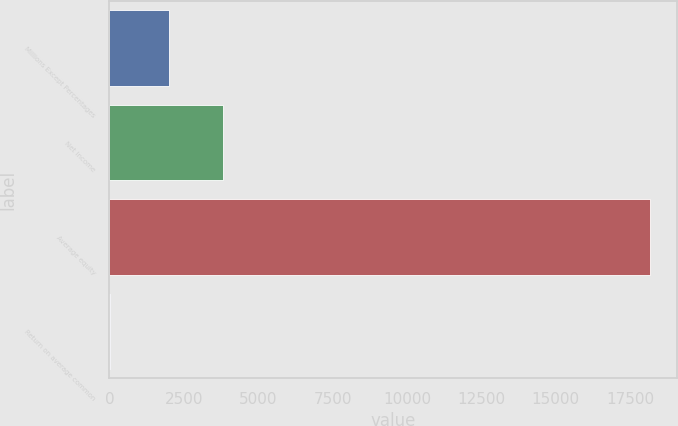Convert chart to OTSL. <chart><loc_0><loc_0><loc_500><loc_500><bar_chart><fcel>Millions Except Percentages<fcel>Net income<fcel>Average equity<fcel>Return on average common<nl><fcel>2011<fcel>3826.29<fcel>18171<fcel>18.1<nl></chart> 